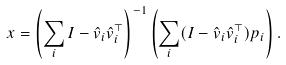<formula> <loc_0><loc_0><loc_500><loc_500>x = \left ( \sum _ { i } I - { \hat { v } } _ { i } { \hat { v } } _ { i } ^ { \top } \right ) ^ { - 1 } \left ( \sum _ { i } ( I - { \hat { v } } _ { i } { \hat { v } } _ { i } ^ { \top } ) p _ { i } \right ) .</formula> 